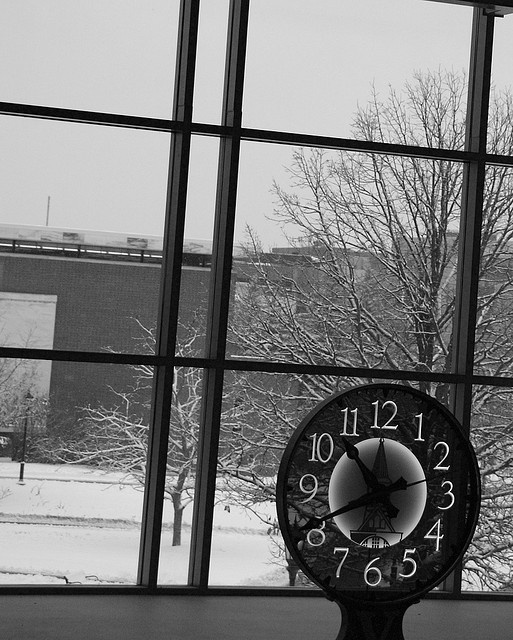Describe the objects in this image and their specific colors. I can see a clock in lightgray, black, gray, darkgray, and gainsboro tones in this image. 